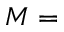<formula> <loc_0><loc_0><loc_500><loc_500>M =</formula> 